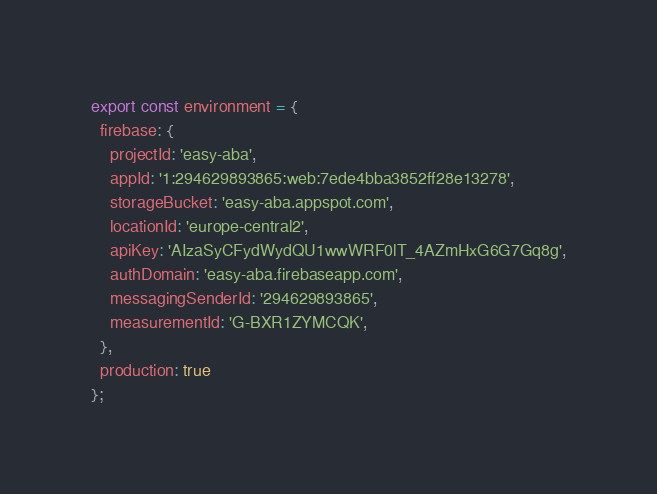Convert code to text. <code><loc_0><loc_0><loc_500><loc_500><_TypeScript_>export const environment = {
  firebase: {
    projectId: 'easy-aba',
    appId: '1:294629893865:web:7ede4bba3852ff28e13278',
    storageBucket: 'easy-aba.appspot.com',
    locationId: 'europe-central2',
    apiKey: 'AIzaSyCFydWydQU1wwWRF0lT_4AZmHxG6G7Gq8g',
    authDomain: 'easy-aba.firebaseapp.com',
    messagingSenderId: '294629893865',
    measurementId: 'G-BXR1ZYMCQK',
  },
  production: true
};
</code> 